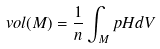Convert formula to latex. <formula><loc_0><loc_0><loc_500><loc_500>\ v o l ( M ) = \frac { 1 } { n } \int _ { M } p H d V</formula> 